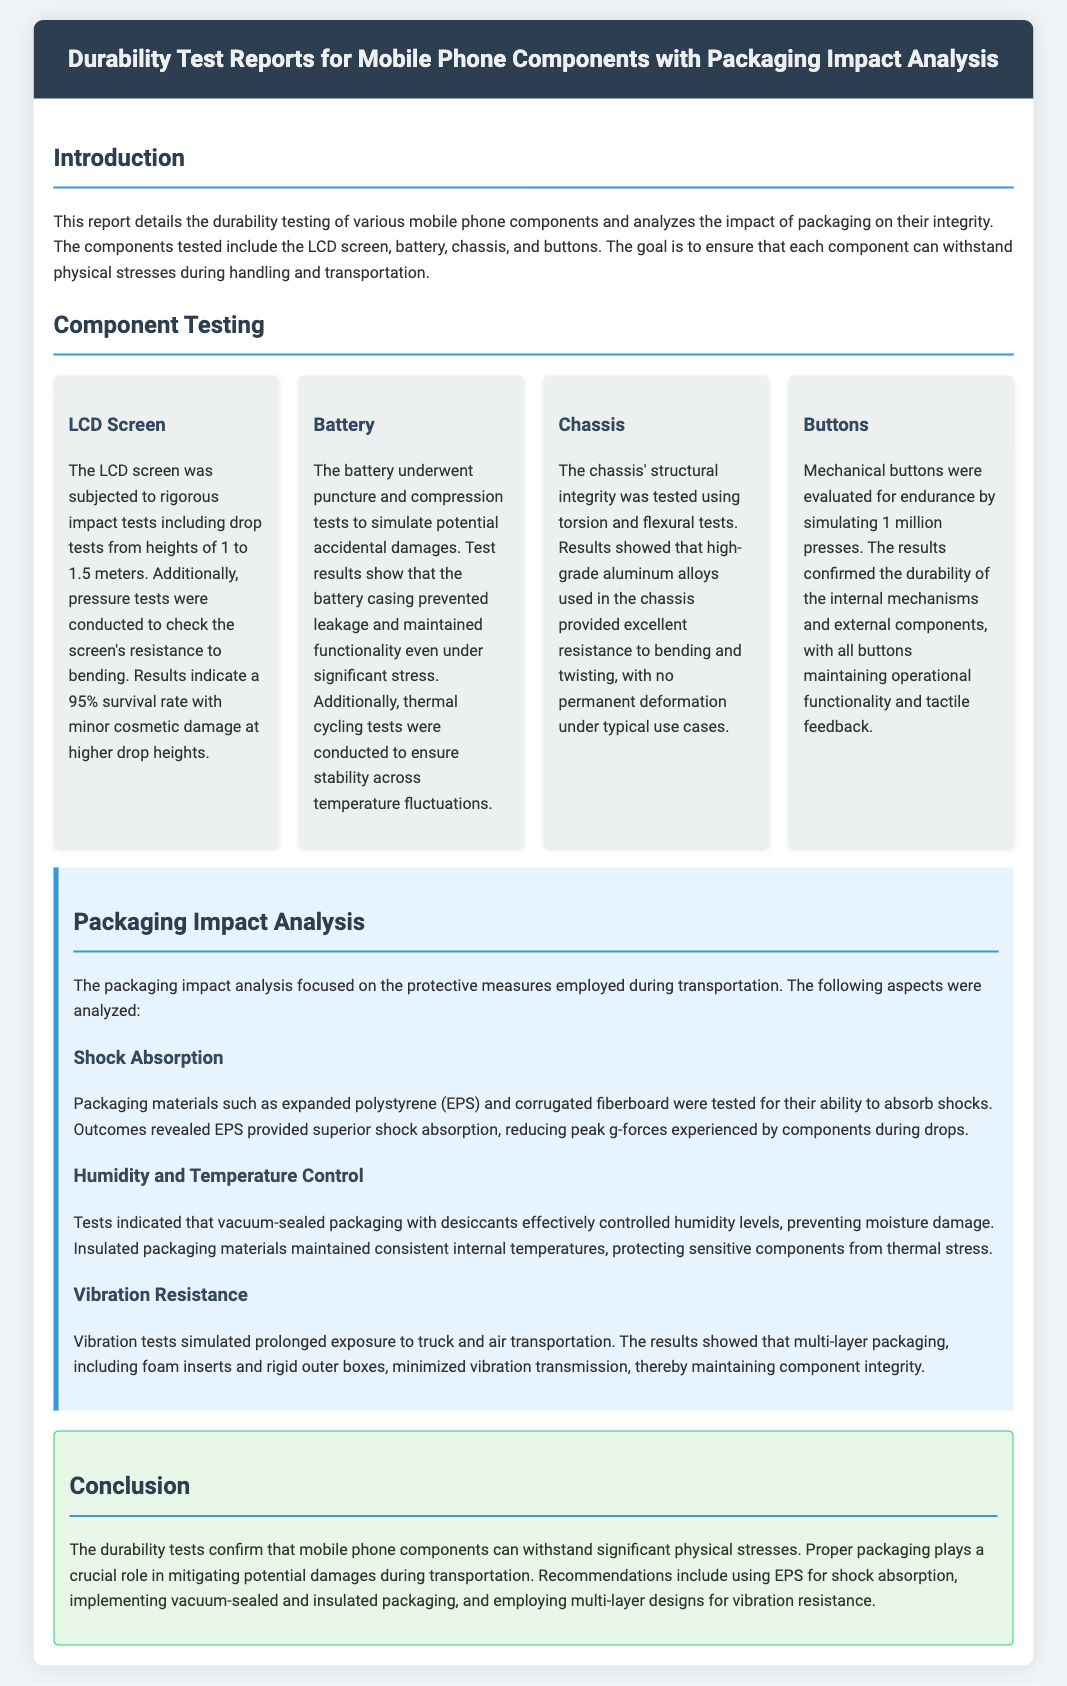what is the survival rate of the LCD screen after drop tests? The document states that results indicate a 95% survival rate with minor cosmetic damage at higher drop heights.
Answer: 95% what materials were analyzed for shock absorption? The document mentions expanded polystyrene (EPS) and corrugated fiberboard as materials tested for shock absorption.
Answer: EPS and corrugated fiberboard how many mechanical button presses were simulated during testing? The testing simulated 1 million presses to evaluate the endurance of mechanical buttons.
Answer: 1 million what type of packaging effectively controls humidity levels? The document states that vacuum-sealed packaging with desiccants effectively controlled humidity levels.
Answer: Vacuum-sealed packaging what is the main protective feature of the multi-layer packaging? The document indicates that multi-layer packaging, including foam inserts and rigid outer boxes, minimized vibration transmission.
Answer: Vibration resistance which component maintained functionality under significant stress according to the battery tests? The test results show that the battery casing prevented leakage and maintained functionality under significant stress.
Answer: Battery casing what was the approach taken to test the chassis's structural integrity? The approach taken involved torsion and flexural tests to assess the chassis's structural integrity.
Answer: Torsion and flexural tests what recommendation is made for packaging to enhance shock absorption? The document recommends using EPS for shock absorption during transportation.
Answer: EPS 